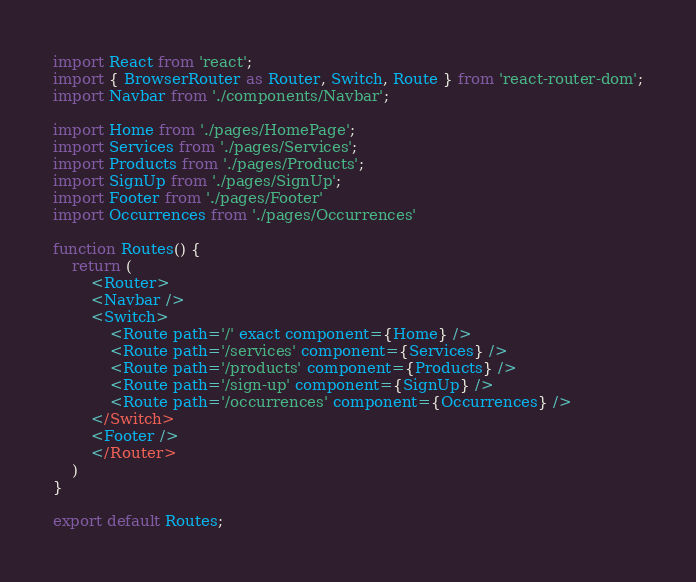<code> <loc_0><loc_0><loc_500><loc_500><_TypeScript_>import React from 'react';
import { BrowserRouter as Router, Switch, Route } from 'react-router-dom';
import Navbar from './components/Navbar';

import Home from './pages/HomePage';
import Services from './pages/Services';
import Products from './pages/Products';
import SignUp from './pages/SignUp';
import Footer from './pages/Footer'
import Occurrences from './pages/Occurrences'

function Routes() {
    return (
        <Router>
        <Navbar />
        <Switch>
            <Route path='/' exact component={Home} />
            <Route path='/services' component={Services} />
            <Route path='/products' component={Products} />
            <Route path='/sign-up' component={SignUp} />
            <Route path='/occurrences' component={Occurrences} />
        </Switch>
        <Footer />
        </Router>
    )
}

export default Routes;


</code> 